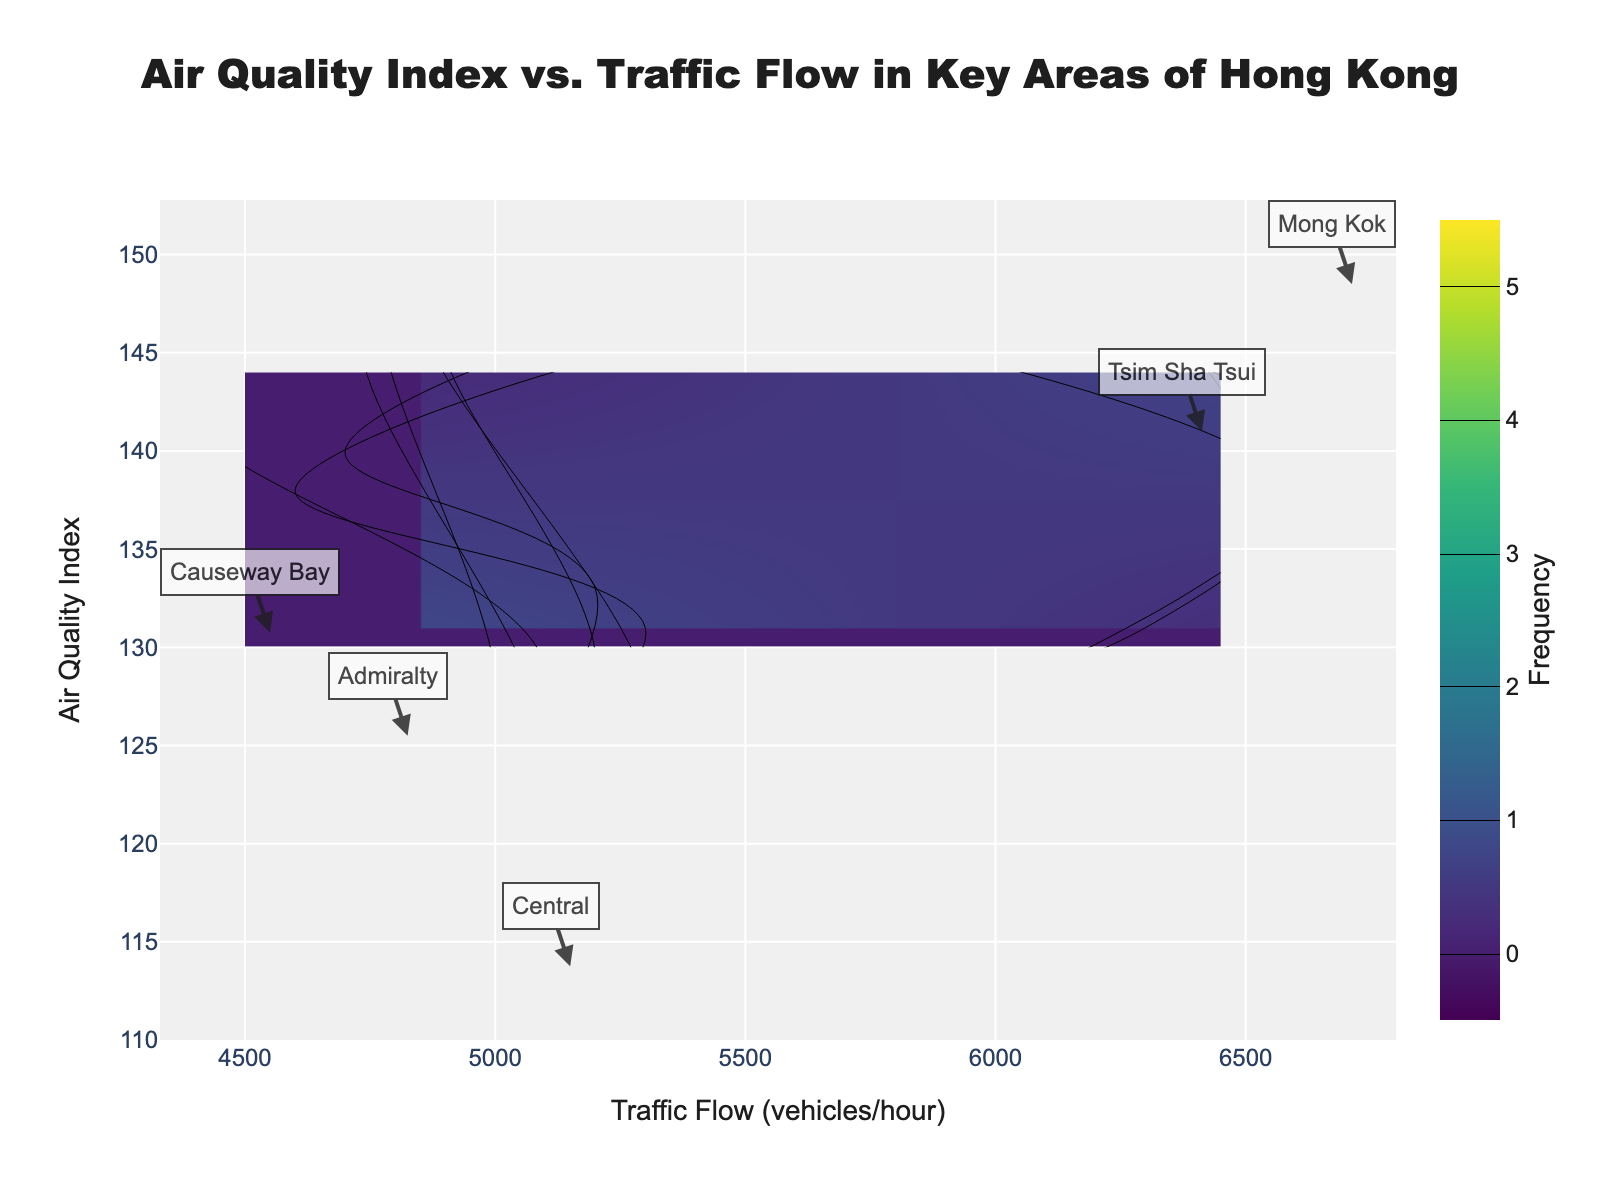What is the title of the contour plot? The title of the contour plot is displayed at the top center of the figure inside the layout configuration section.
Answer: Air Quality Index vs. Traffic Flow in Key Areas of Hong Kong What are the axis titles of the contour plot? The x-axis title is specified in the layout section under "xaxis_title" and the y-axis title is under "yaxis_title".
Answer: Traffic Flow (vehicles/hour) and Air Quality Index Which location has the highest average traffic flow? To find the location with the highest average traffic flow, look for the annotations on the figure. Calculate the mean traffic flow for each location and compare them. Mong Kok has the highest individual traffic flow values (6700, 6800, 6600, 6750). The mean of these values is higher than that of other locations.
Answer: Mong Kok How does the air quality index correlate with traffic flow in Mong Kok compared to Tsim Sha Tsui? Look at the contour density and the mean values of the annotations for Mong Kok and Tsim Sha Tsui. Mong Kok typically has higher traffic flow and also a higher air quality index than Tsim Sha Tsui.
Answer: In Mong Kok, higher traffic flow correlates with a higher air quality index compared to Tsim Sha Tsui Which location exhibits the largest variability in traffic flow? To determine this, observe the annotations for each location and see which one has the widest range of traffic flow values. Mong Kok has traffic flow ranging from 6600 to 6800, which is a broader range compared to other locations.
Answer: Mong Kok What is the frequency contour range shown in the plot? The contour plot's frequency range can be found under the "contours" dictionary, specifically in the "start" and "end" attributes.
Answer: 0 to 5 How many levels of contour are there in the plot? The number of contour levels is determined by the difference between the "start" and "end" values divided by the "size" value in the contours dictionary. So we have (5-0)/1 = 5 levels.
Answer: 5 Is there a point where traffic flow is at its maximum but AQI is low? By examining the contour density and locating where higher traffic flow values intersect with lower AQI values. It’s likely to be in Central where the data points show higher traffic flow but relatively lower AQI.
Answer: Central What is the median traffic flow for all areas in Hong Kong based on the plot data? To find the median, list all traffic flow values and find the middle value. The values are 4400, 4500, 4600, 4700, 4750, 4800, 4850, 4900, 5000, 5100, 5200, 5300, 6300, 6400, 6450, 6500, 6600, 6700, 6750, 6800. The median value, which is the 10th of these sorted values, is 5000.
Answer: 5000 